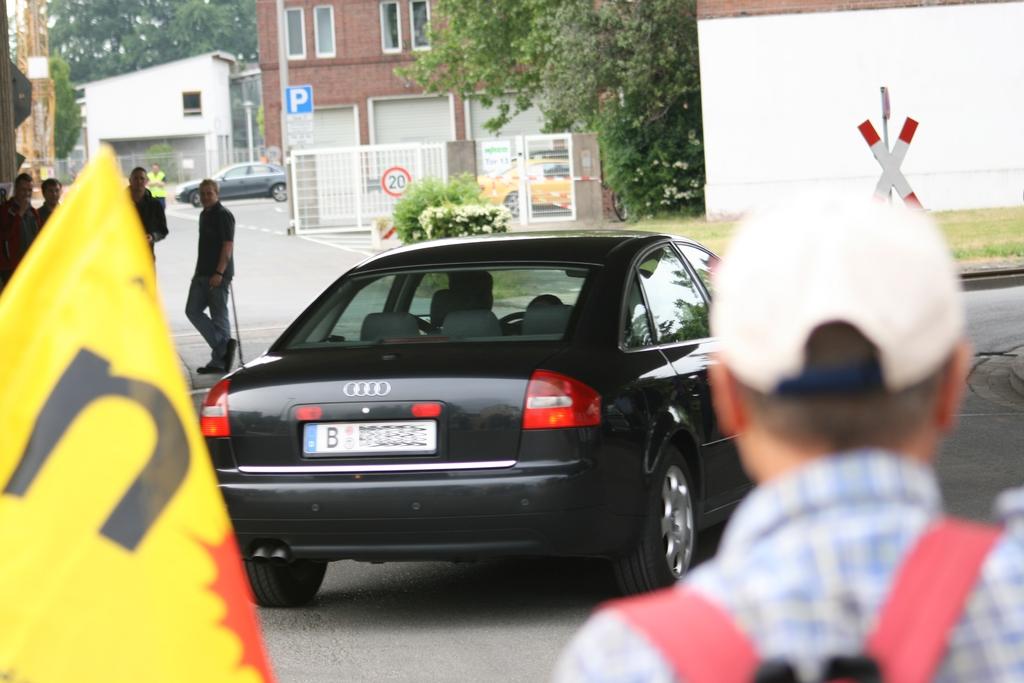What is the cars license number?
Your response must be concise. Unanswerable. 